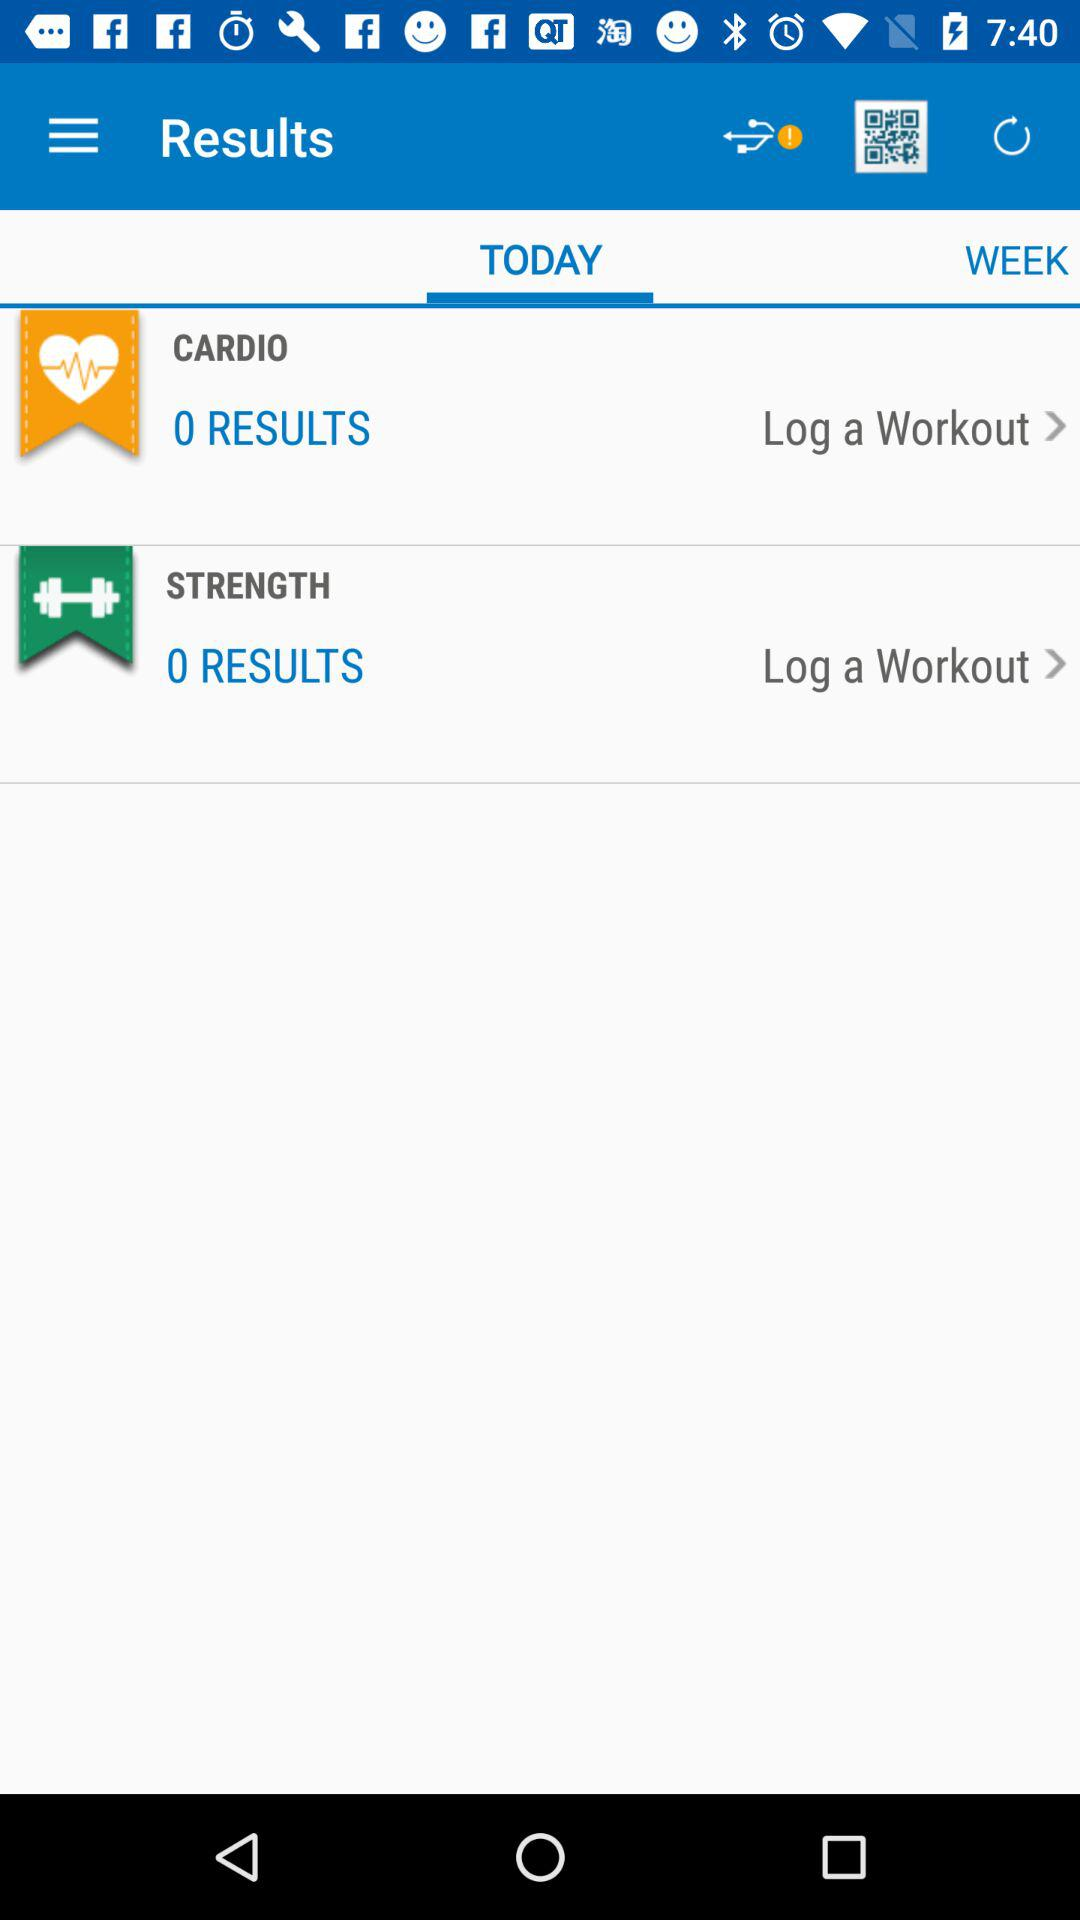What is the number of results for the strength workout? The number of results is 0. 